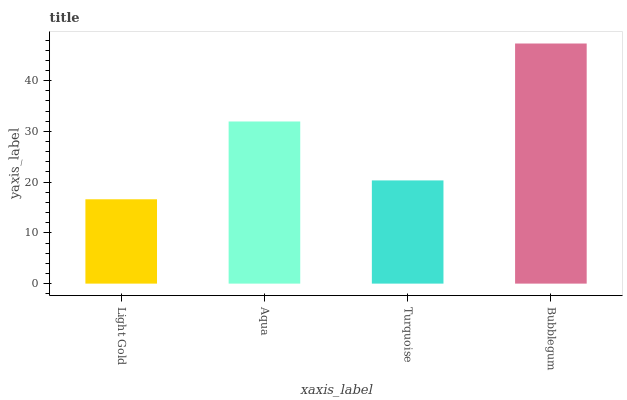Is Aqua the minimum?
Answer yes or no. No. Is Aqua the maximum?
Answer yes or no. No. Is Aqua greater than Light Gold?
Answer yes or no. Yes. Is Light Gold less than Aqua?
Answer yes or no. Yes. Is Light Gold greater than Aqua?
Answer yes or no. No. Is Aqua less than Light Gold?
Answer yes or no. No. Is Aqua the high median?
Answer yes or no. Yes. Is Turquoise the low median?
Answer yes or no. Yes. Is Light Gold the high median?
Answer yes or no. No. Is Light Gold the low median?
Answer yes or no. No. 